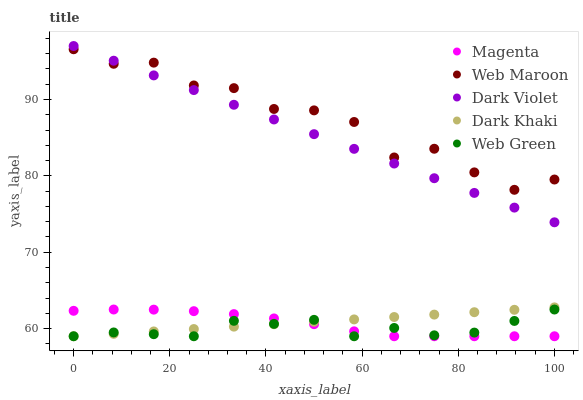Does Web Green have the minimum area under the curve?
Answer yes or no. Yes. Does Web Maroon have the maximum area under the curve?
Answer yes or no. Yes. Does Magenta have the minimum area under the curve?
Answer yes or no. No. Does Magenta have the maximum area under the curve?
Answer yes or no. No. Is Dark Khaki the smoothest?
Answer yes or no. Yes. Is Web Maroon the roughest?
Answer yes or no. Yes. Is Magenta the smoothest?
Answer yes or no. No. Is Magenta the roughest?
Answer yes or no. No. Does Dark Khaki have the lowest value?
Answer yes or no. Yes. Does Web Maroon have the lowest value?
Answer yes or no. No. Does Dark Violet have the highest value?
Answer yes or no. Yes. Does Web Maroon have the highest value?
Answer yes or no. No. Is Web Green less than Dark Violet?
Answer yes or no. Yes. Is Web Maroon greater than Web Green?
Answer yes or no. Yes. Does Magenta intersect Dark Khaki?
Answer yes or no. Yes. Is Magenta less than Dark Khaki?
Answer yes or no. No. Is Magenta greater than Dark Khaki?
Answer yes or no. No. Does Web Green intersect Dark Violet?
Answer yes or no. No. 